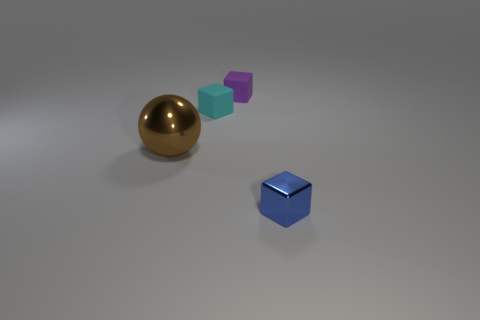Subtract all small cyan blocks. How many blocks are left? 2 Add 2 large brown metal things. How many objects exist? 6 Subtract all cubes. How many objects are left? 1 Add 4 brown things. How many brown things are left? 5 Add 4 large green rubber blocks. How many large green rubber blocks exist? 4 Subtract 0 blue spheres. How many objects are left? 4 Subtract all gray blocks. Subtract all green cylinders. How many blocks are left? 3 Subtract all blue metal blocks. Subtract all shiny objects. How many objects are left? 1 